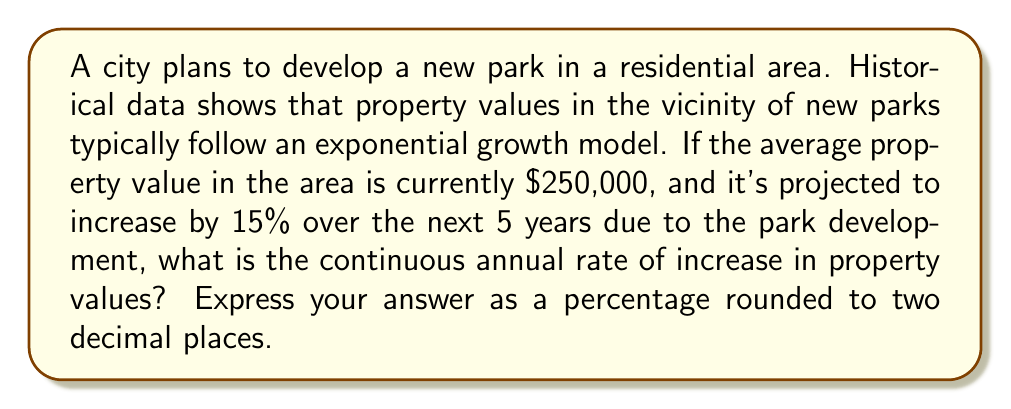Help me with this question. Let's approach this step-by-step using the exponential growth model:

1) The exponential growth model is given by:
   $$A = P \cdot e^{rt}$$
   where:
   $A$ = final amount
   $P$ = initial principal (starting amount)
   $r$ = continuous annual rate of increase
   $t$ = time in years

2) We know:
   $P = \$250,000$ (initial property value)
   $A = \$250,000 \cdot 1.15 = \$287,500$ (final property value after 15% increase)
   $t = 5$ years

3) Substituting these values into the equation:
   $$287,500 = 250,000 \cdot e^{5r}$$

4) Divide both sides by 250,000:
   $$1.15 = e^{5r}$$

5) Take the natural logarithm of both sides:
   $$\ln(1.15) = \ln(e^{5r})$$

6) Simplify the right side using the properties of logarithms:
   $$\ln(1.15) = 5r$$

7) Solve for $r$:
   $$r = \frac{\ln(1.15)}{5}$$

8) Calculate the value of $r$:
   $$r \approx 0.0279$$

9) Convert to a percentage:
   $$r \approx 2.79\%$$

Therefore, the continuous annual rate of increase in property values is approximately 2.79%.
Answer: 2.79% 